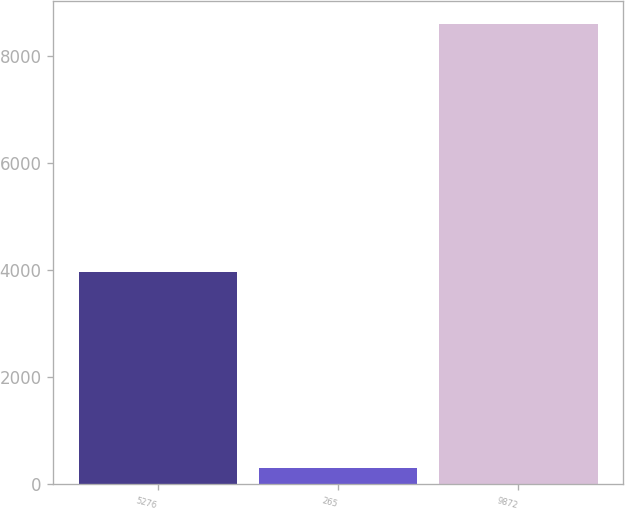<chart> <loc_0><loc_0><loc_500><loc_500><bar_chart><fcel>5276<fcel>265<fcel>9872<nl><fcel>3964<fcel>305<fcel>8600<nl></chart> 